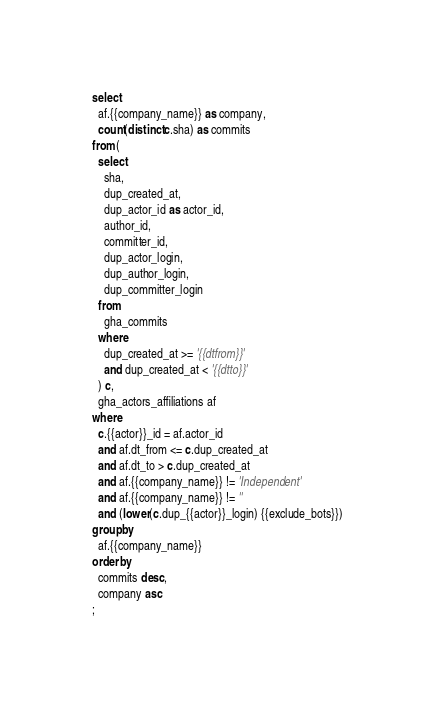Convert code to text. <code><loc_0><loc_0><loc_500><loc_500><_SQL_>select
  af.{{company_name}} as company,
  count(distinct c.sha) as commits
from (
  select
    sha,
    dup_created_at,
    dup_actor_id as actor_id,
    author_id,
    committer_id,
    dup_actor_login,
    dup_author_login,
    dup_committer_login
  from
    gha_commits
  where
    dup_created_at >= '{{dtfrom}}'
    and dup_created_at < '{{dtto}}'
  ) c,
  gha_actors_affiliations af
where
  c.{{actor}}_id = af.actor_id
  and af.dt_from <= c.dup_created_at
  and af.dt_to > c.dup_created_at
  and af.{{company_name}} != 'Independent'
  and af.{{company_name}} != ''
  and (lower(c.dup_{{actor}}_login) {{exclude_bots}})
group by
  af.{{company_name}}
order by
  commits desc,
  company asc
;
</code> 